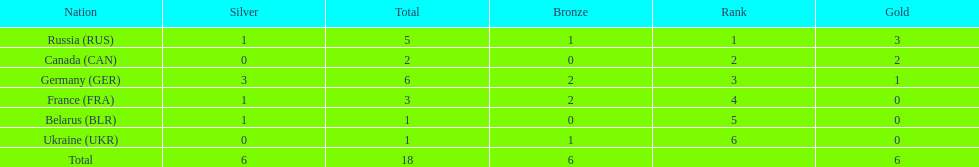How many silver medals did belarus win? 1. 